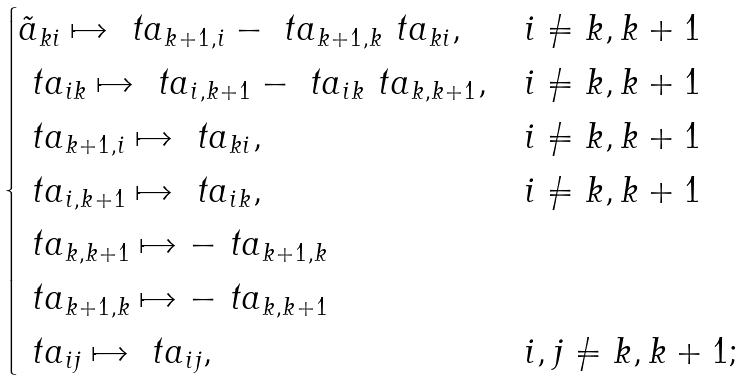Convert formula to latex. <formula><loc_0><loc_0><loc_500><loc_500>\begin{cases} \tilde { a } _ { k i } \mapsto \ t a _ { k + 1 , i } - \ t a _ { k + 1 , k } \ t a _ { k i } , & i \neq k , k + 1 \\ \ t a _ { i k } \mapsto \ t a _ { i , k + 1 } - \ t a _ { i k } \ t a _ { k , k + 1 } , & i \neq k , k + 1 \\ \ t a _ { k + 1 , i } \mapsto \ t a _ { k i } , & i \neq k , k + 1 \\ \ t a _ { i , k + 1 } \mapsto \ t a _ { i k } , & i \neq k , k + 1 \\ \ t a _ { k , k + 1 } \mapsto - \ t a _ { k + 1 , k } & \\ \ t a _ { k + 1 , k } \mapsto - \ t a _ { k , k + 1 } & \\ \ t a _ { i j } \mapsto \ t a _ { i j } , & i , j \neq k , k + 1 ; \end{cases}</formula> 